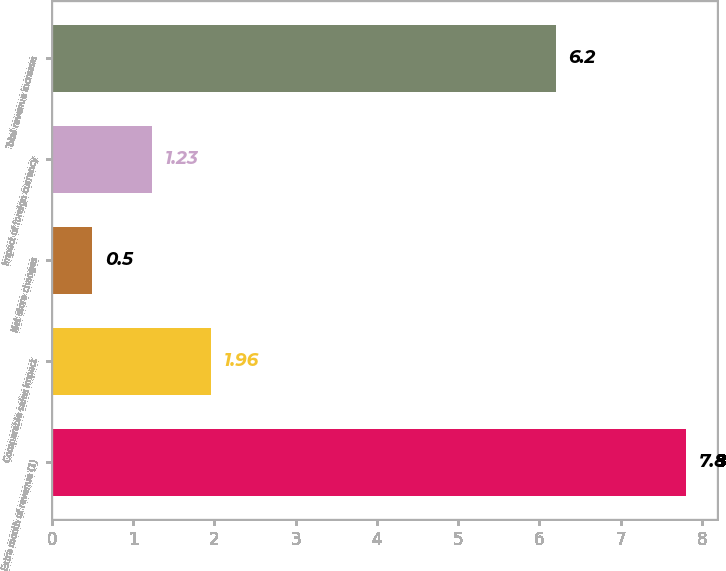<chart> <loc_0><loc_0><loc_500><loc_500><bar_chart><fcel>Extra month of revenue (1)<fcel>Comparable sales impact<fcel>Net store changes<fcel>Impact of foreign currency<fcel>Total revenue increase<nl><fcel>7.8<fcel>1.96<fcel>0.5<fcel>1.23<fcel>6.2<nl></chart> 